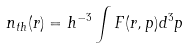<formula> <loc_0><loc_0><loc_500><loc_500>n _ { t h } ( { r } ) = h ^ { - 3 } \int F ( { r } , { p } ) d ^ { 3 } { p }</formula> 